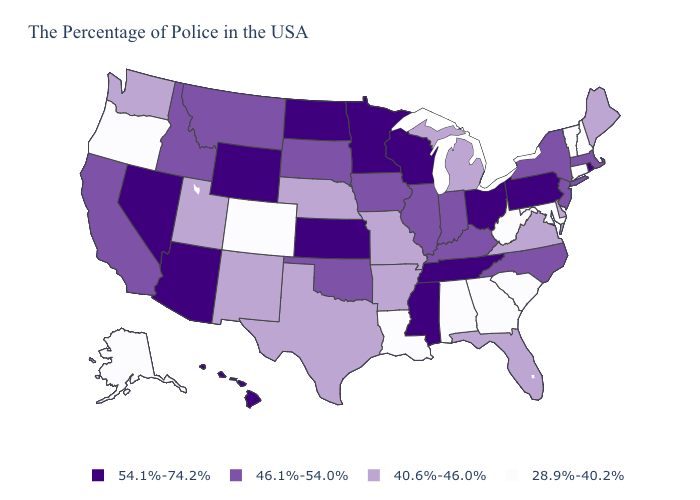What is the highest value in the USA?
Give a very brief answer. 54.1%-74.2%. Name the states that have a value in the range 40.6%-46.0%?
Keep it brief. Maine, Delaware, Virginia, Florida, Michigan, Missouri, Arkansas, Nebraska, Texas, New Mexico, Utah, Washington. What is the value of Nebraska?
Short answer required. 40.6%-46.0%. What is the lowest value in states that border New Mexico?
Answer briefly. 28.9%-40.2%. Name the states that have a value in the range 54.1%-74.2%?
Concise answer only. Rhode Island, Pennsylvania, Ohio, Tennessee, Wisconsin, Mississippi, Minnesota, Kansas, North Dakota, Wyoming, Arizona, Nevada, Hawaii. What is the value of Colorado?
Answer briefly. 28.9%-40.2%. Does Ohio have the highest value in the USA?
Quick response, please. Yes. Among the states that border West Virginia , does Pennsylvania have the highest value?
Keep it brief. Yes. What is the value of Vermont?
Keep it brief. 28.9%-40.2%. What is the lowest value in the Northeast?
Short answer required. 28.9%-40.2%. Does Kansas have the same value as Colorado?
Give a very brief answer. No. What is the lowest value in states that border Connecticut?
Concise answer only. 46.1%-54.0%. Which states have the lowest value in the MidWest?
Be succinct. Michigan, Missouri, Nebraska. Does the map have missing data?
Be succinct. No. 